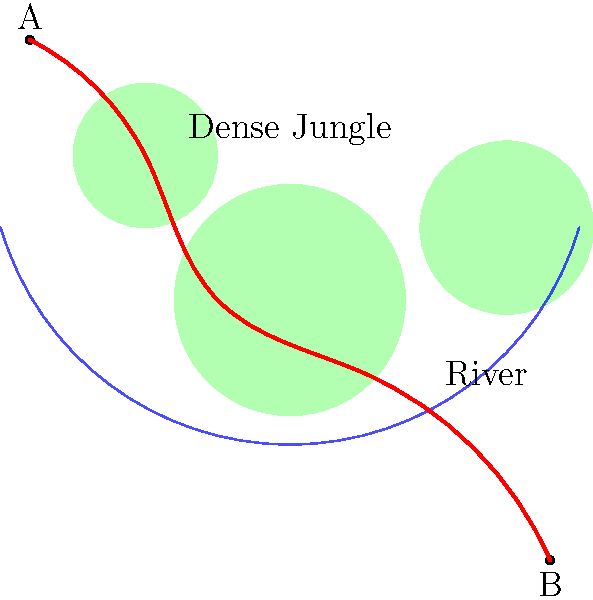Based on the aerial view of a jungle terrain, which path would be most efficient for an archaeological expedition to travel from point A to point B while minimizing encounters with dense vegetation and water obstacles? To determine the most efficient path, we need to consider the following factors:

1. Density of jungle: The green circular areas represent dense jungle, which should be avoided when possible.
2. Water obstacles: The blue curved line represents a river, which is challenging to cross.
3. Distance: The path should be as direct as possible while avoiding obstacles.

Analyzing the map, we can see that:

1. There are three main areas of dense jungle to navigate around.
2. The river curves through the center of the map.
3. Points A and B are diagonally opposite each other.

The most efficient path would:

1. Start from point A and skirt the edge of the dense jungle area to the north.
2. Move southeast, passing between two dense jungle areas.
3. Cross the river at its narrowest point, which is approximately in the center of the map.
4. Continue southeast, avoiding the dense jungle area to the south.
5. Arrive at point B.

This path, shown in red on the map, minimizes encounters with dense vegetation by passing between jungle areas rather than through them. It also crosses the river at its narrowest point, reducing the difficulty of water crossing. The path maintains a relatively direct route from A to B while navigating around obstacles efficiently.
Answer: The red curved path between dense jungle areas, crossing the river at its narrowest point. 